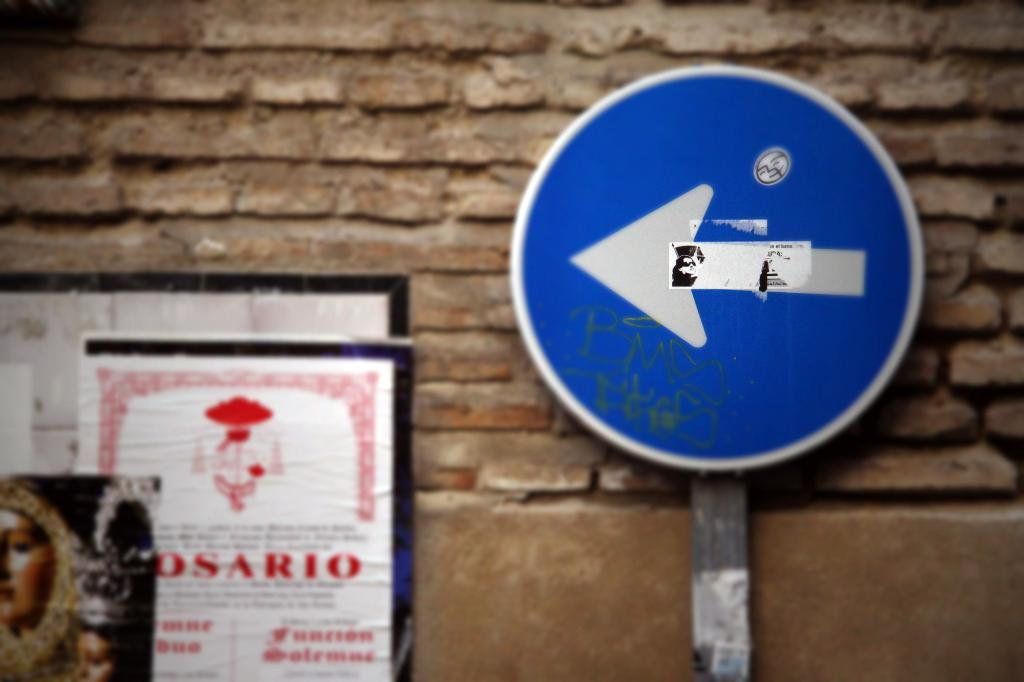What is located on the right side of the image? There is a sign pole on the right side of the image. What can be seen on the left side of the image? There are posters on the left side of the image. What is visible in the background of the image? There is a wall in the background of the image. What verse is written on the sign pole in the image? There is no verse present on the sign pole in the image; it is a pole with signs attached to it. Who is the owner of the posters on the left side of the image? The image does not provide information about the ownership of the posters, so it cannot be determined from the image. 